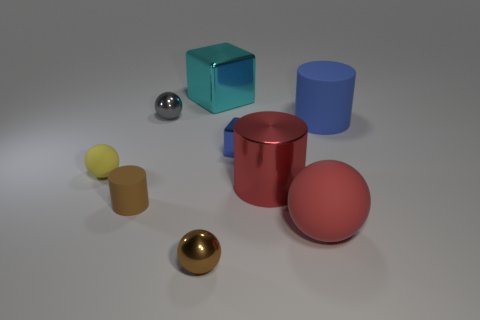What is the small blue thing made of?
Keep it short and to the point. Metal. What color is the metallic object that is behind the tiny gray ball?
Your answer should be very brief. Cyan. Is the number of big blue matte things in front of the blue metallic cube greater than the number of small blue cubes that are behind the cyan shiny thing?
Provide a short and direct response. No. What is the size of the rubber cylinder to the left of the tiny ball right of the tiny gray metallic thing in front of the cyan thing?
Provide a short and direct response. Small. Is there a tiny metal ball that has the same color as the big block?
Offer a very short reply. No. How many metal balls are there?
Your response must be concise. 2. The block in front of the tiny metallic ball that is behind the large cylinder left of the large blue matte cylinder is made of what material?
Offer a very short reply. Metal. Are there any big gray objects that have the same material as the big blue thing?
Your answer should be very brief. No. Is the material of the tiny brown sphere the same as the big ball?
Your response must be concise. No. What number of balls are blue rubber objects or tiny yellow things?
Offer a very short reply. 1. 